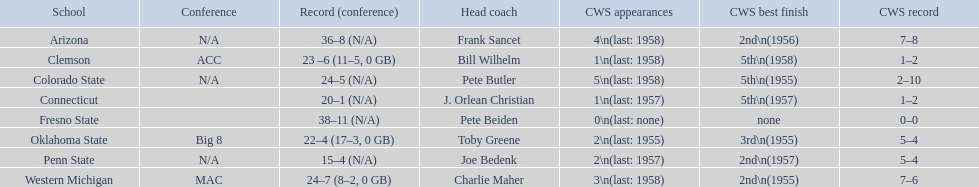What are all the academic institutions? Arizona, Clemson, Colorado State, Connecticut, Fresno State, Oklahoma State, Penn State, Western Michigan. Which group had lesser than 20 triumphs? Penn State. What are the names of every school? Arizona, Clemson, Colorado State, Connecticut, Fresno State, Oklahoma State, Penn State, Western Michigan. What is the track record for each? 36–8 (N/A), 23 –6 (11–5, 0 GB), 24–5 (N/A), 20–1 (N/A), 38–11 (N/A), 22–4 (17–3, 0 GB), 15–4 (N/A), 24–7 (8–2, 0 GB). Which institution had the smallest number of wins? Penn State. 